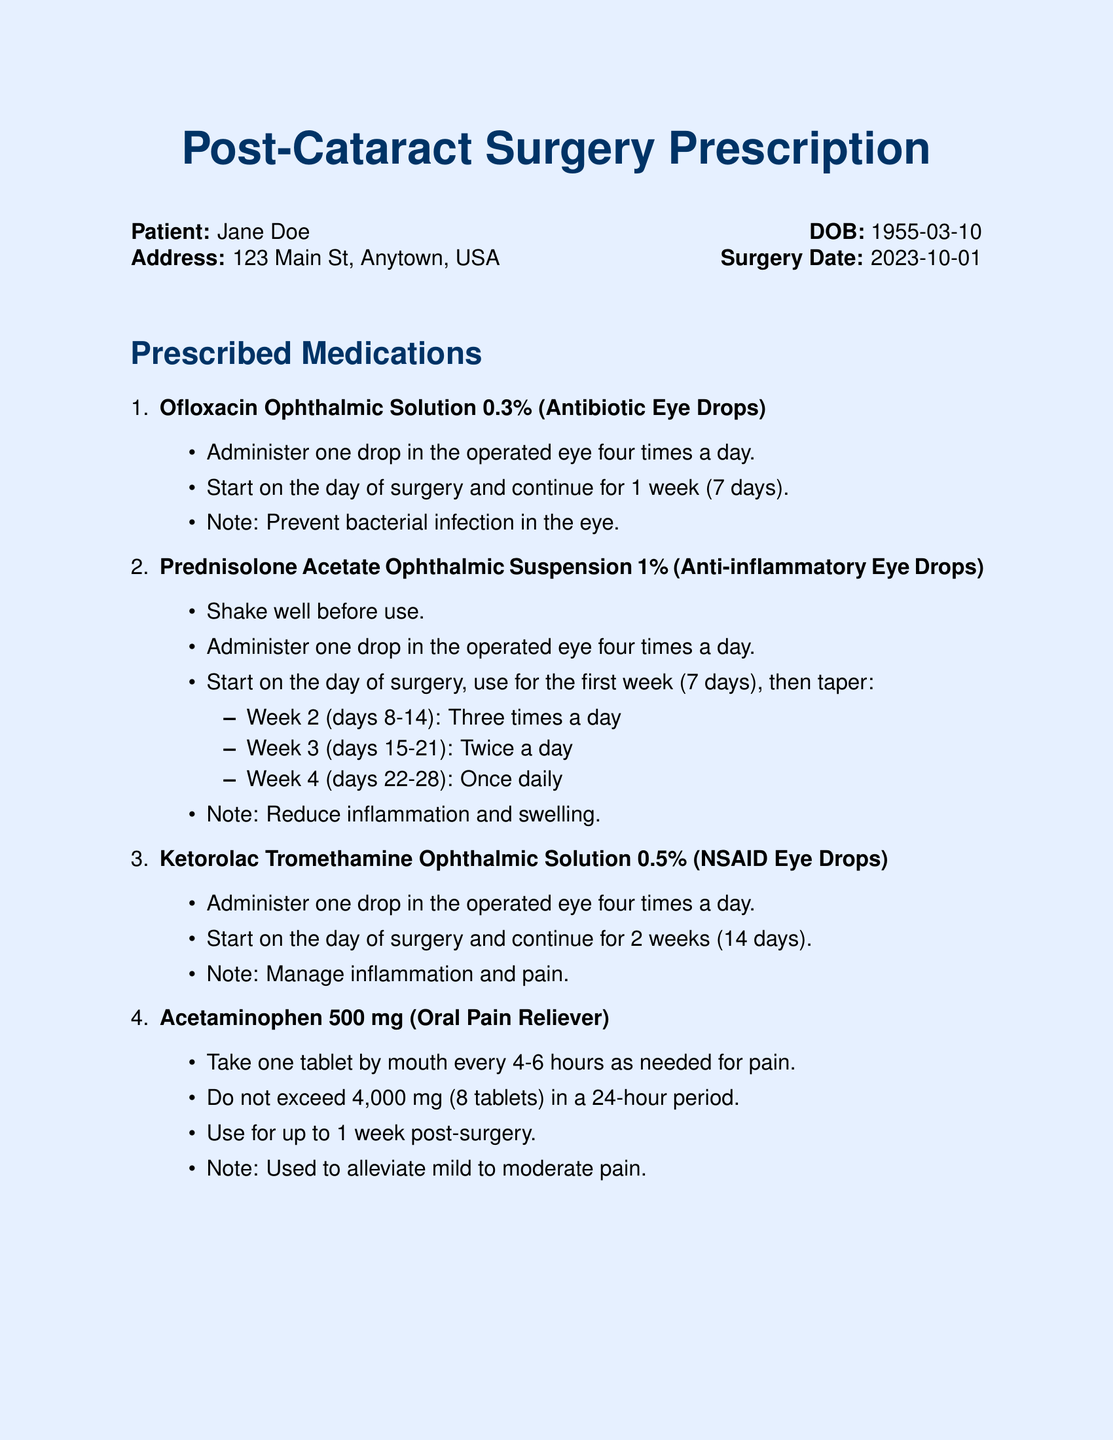What is the prescribed antibiotic eye drop? The document specifies Ofloxacin Ophthalmic Solution 0.3%.
Answer: Ofloxacin Ophthalmic Solution 0.3% How many drops should be administered daily? The instructions indicate to administer four drops per day.
Answer: Four times a day What is the duration for taking the antibiotic drops? The document states to continue for 1 week (7 days).
Answer: 1 week (7 days) What is the first week dosage for the anti-inflammatory eye drops? The first week dosage is four times a day.
Answer: Four times a day What is the maximum acetaminophen dosage allowed in 24 hours? The document mentions not exceeding 4,000 mg.
Answer: 4,000 mg What type of medication is Ketorolac Tromethamine? Ketorolac Tromethamine is classified as NSAID Eye Drops.
Answer: NSAID Eye Drops When should the eye shield be worn? The instructions state to wear the eye shield at night for at least one week.
Answer: At night for at least one week What should be reported to the ophthalmologist? The document instructs to report any severe pain or sudden vision changes.
Answer: Severe pain or sudden vision changes How long should the Ketorolac drops be used? The duration for the Ketorolac is 2 weeks (14 days).
Answer: 2 weeks (14 days) 